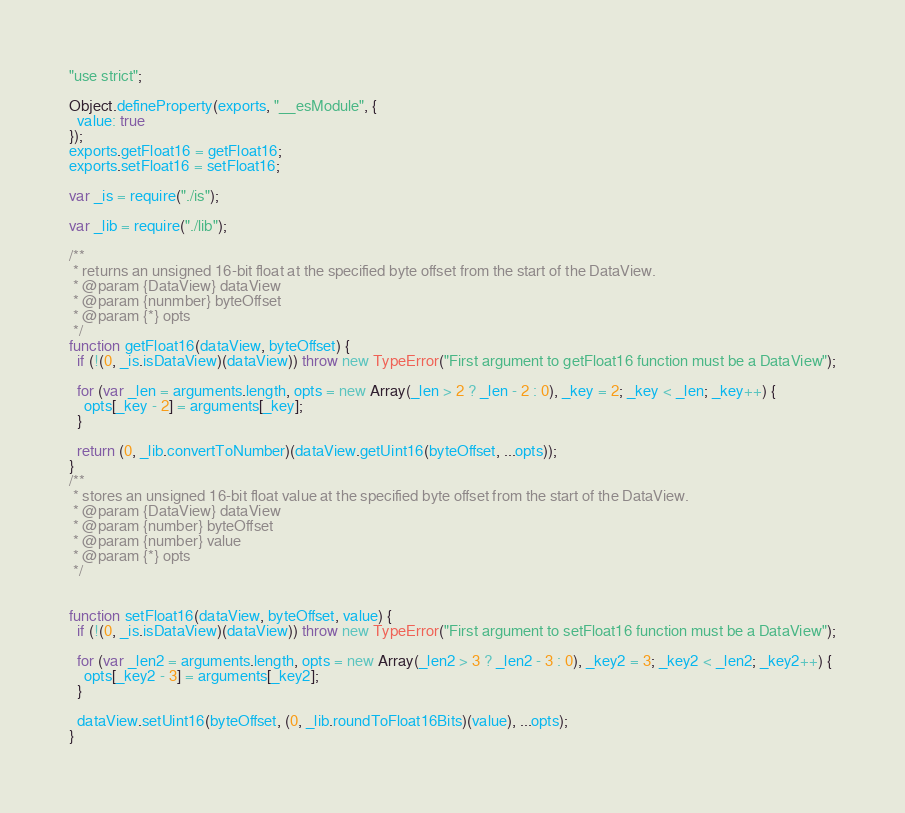Convert code to text. <code><loc_0><loc_0><loc_500><loc_500><_JavaScript_>"use strict";

Object.defineProperty(exports, "__esModule", {
  value: true
});
exports.getFloat16 = getFloat16;
exports.setFloat16 = setFloat16;

var _is = require("./is");

var _lib = require("./lib");

/**
 * returns an unsigned 16-bit float at the specified byte offset from the start of the DataView.
 * @param {DataView} dataView
 * @param {nunmber} byteOffset
 * @param {*} opts
 */
function getFloat16(dataView, byteOffset) {
  if (!(0, _is.isDataView)(dataView)) throw new TypeError("First argument to getFloat16 function must be a DataView");

  for (var _len = arguments.length, opts = new Array(_len > 2 ? _len - 2 : 0), _key = 2; _key < _len; _key++) {
    opts[_key - 2] = arguments[_key];
  }

  return (0, _lib.convertToNumber)(dataView.getUint16(byteOffset, ...opts));
}
/**
 * stores an unsigned 16-bit float value at the specified byte offset from the start of the DataView.
 * @param {DataView} dataView
 * @param {number} byteOffset
 * @param {number} value
 * @param {*} opts
 */


function setFloat16(dataView, byteOffset, value) {
  if (!(0, _is.isDataView)(dataView)) throw new TypeError("First argument to setFloat16 function must be a DataView");

  for (var _len2 = arguments.length, opts = new Array(_len2 > 3 ? _len2 - 3 : 0), _key2 = 3; _key2 < _len2; _key2++) {
    opts[_key2 - 3] = arguments[_key2];
  }

  dataView.setUint16(byteOffset, (0, _lib.roundToFloat16Bits)(value), ...opts);
}</code> 